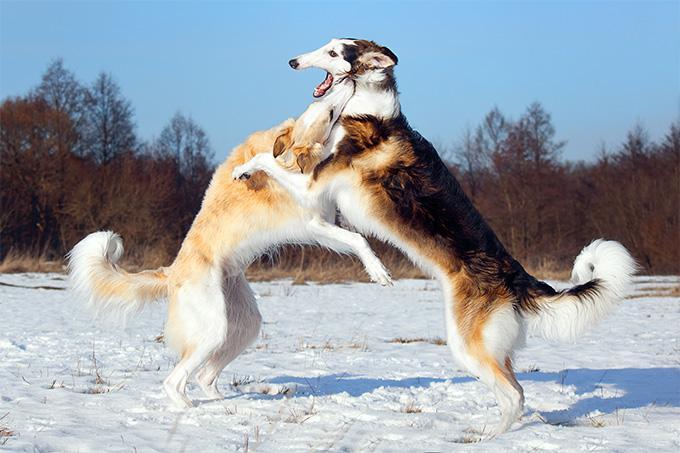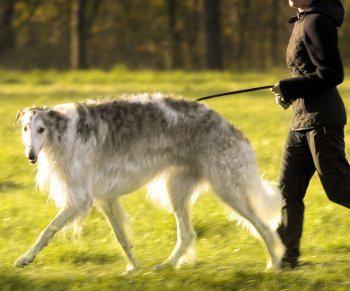The first image is the image on the left, the second image is the image on the right. Evaluate the accuracy of this statement regarding the images: "There is exactly one dog in each image.". Is it true? Answer yes or no. No. The first image is the image on the left, the second image is the image on the right. Examine the images to the left and right. Is the description "There are at least two dogs in the image on the left." accurate? Answer yes or no. Yes. 